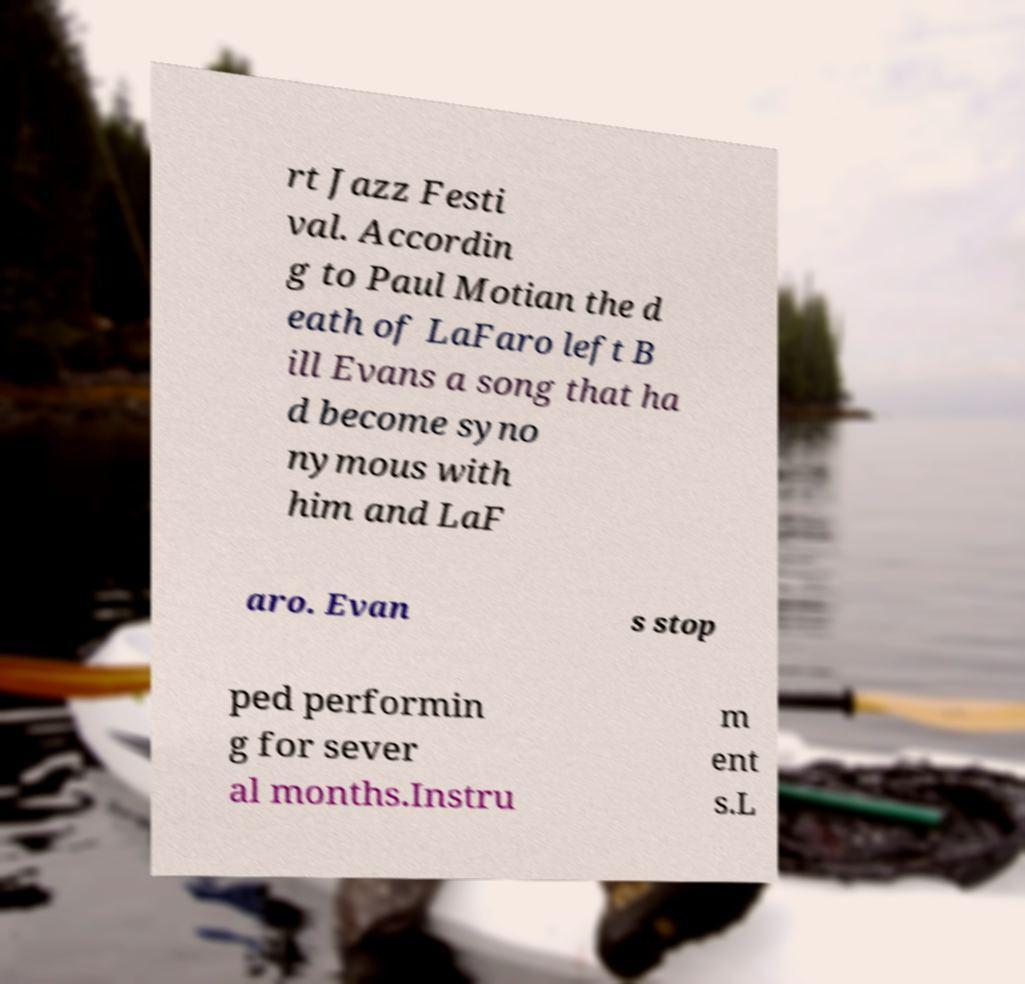For documentation purposes, I need the text within this image transcribed. Could you provide that? rt Jazz Festi val. Accordin g to Paul Motian the d eath of LaFaro left B ill Evans a song that ha d become syno nymous with him and LaF aro. Evan s stop ped performin g for sever al months.Instru m ent s.L 